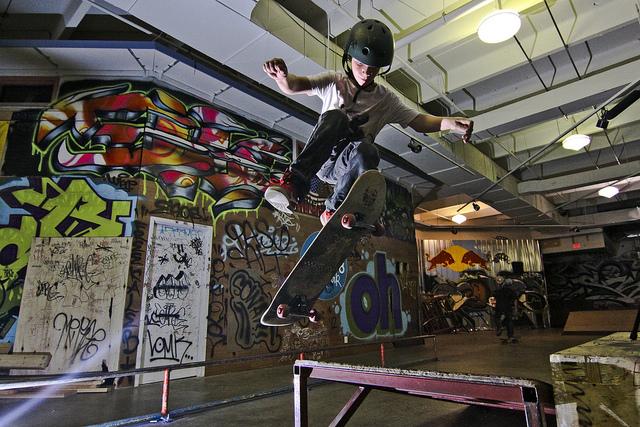How many feet does the male have touching the skateboard?
Give a very brief answer. 1. What is the boy riding on?
Keep it brief. Skateboard. Are the lights shining on the back or front of the person in the air?
Short answer required. Back. Is there graffiti?
Keep it brief. Yes. 